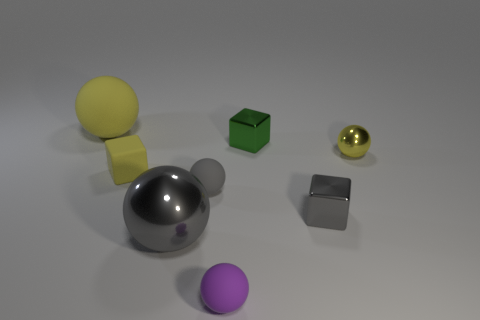The small metallic object that is the same color as the large shiny sphere is what shape?
Your response must be concise. Cube. How many objects are the same size as the purple rubber ball?
Give a very brief answer. 5. Is the size of the yellow ball that is to the right of the purple matte object the same as the metal sphere that is left of the small green metallic object?
Your answer should be compact. No. What number of things are red matte objects or matte things that are on the right side of the large matte object?
Your response must be concise. 3. What is the color of the big metal object?
Provide a short and direct response. Gray. There is a yellow sphere right of the big sphere that is left of the tiny yellow thing left of the gray metal block; what is its material?
Your answer should be compact. Metal. The gray ball that is the same material as the yellow cube is what size?
Your response must be concise. Small. Is there a shiny thing that has the same color as the big rubber object?
Keep it short and to the point. Yes. There is a purple ball; is its size the same as the yellow shiny object to the right of the large yellow ball?
Offer a terse response. Yes. What number of big yellow balls are left of the large gray sphere that is right of the big object behind the gray shiny block?
Ensure brevity in your answer.  1. 